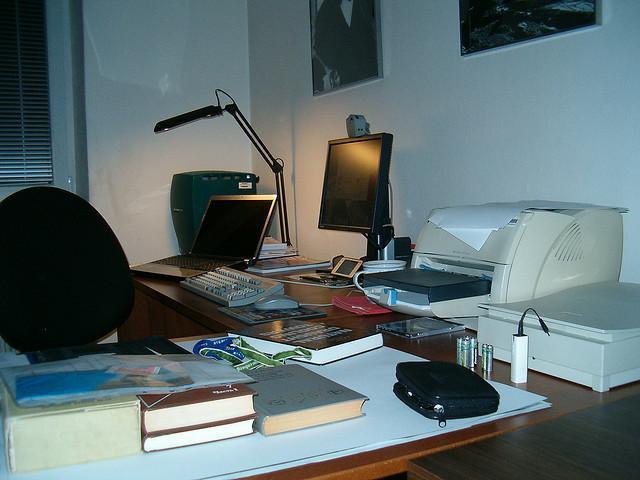How many laptops are on the lady's desk?
Give a very brief answer. 1. How many books are in the picture?
Give a very brief answer. 4. 